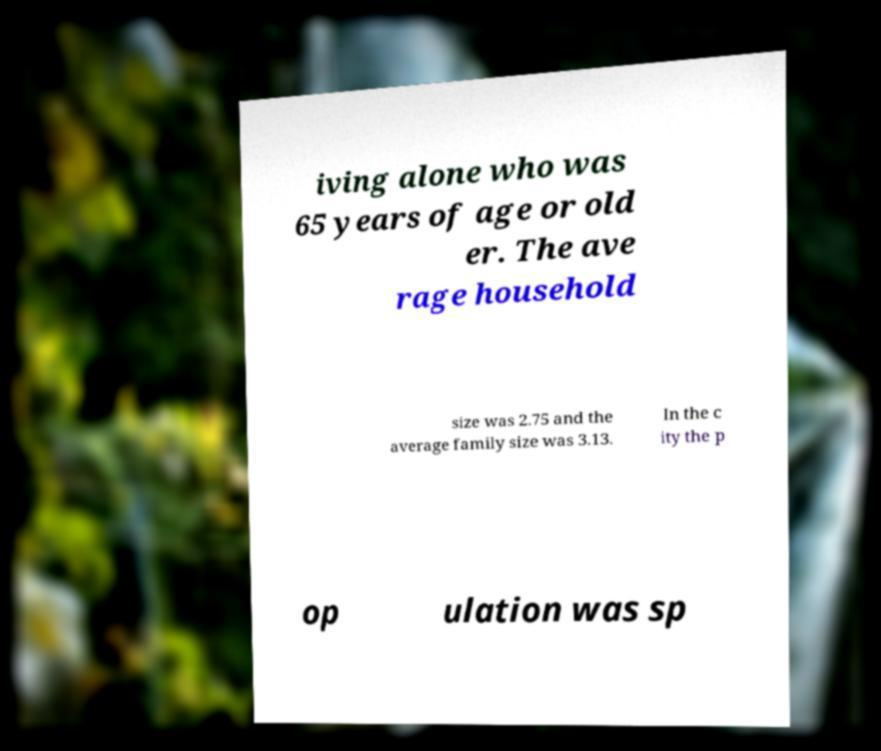Could you assist in decoding the text presented in this image and type it out clearly? iving alone who was 65 years of age or old er. The ave rage household size was 2.75 and the average family size was 3.13. In the c ity the p op ulation was sp 